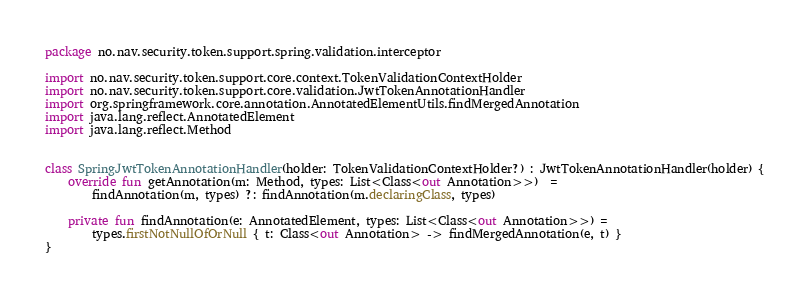Convert code to text. <code><loc_0><loc_0><loc_500><loc_500><_Kotlin_>package no.nav.security.token.support.spring.validation.interceptor

import no.nav.security.token.support.core.context.TokenValidationContextHolder
import no.nav.security.token.support.core.validation.JwtTokenAnnotationHandler
import org.springframework.core.annotation.AnnotatedElementUtils.findMergedAnnotation
import java.lang.reflect.AnnotatedElement
import java.lang.reflect.Method


class SpringJwtTokenAnnotationHandler(holder: TokenValidationContextHolder?) : JwtTokenAnnotationHandler(holder) {
    override fun getAnnotation(m: Method, types: List<Class<out Annotation>>)  =
        findAnnotation(m, types) ?: findAnnotation(m.declaringClass, types)

    private fun findAnnotation(e: AnnotatedElement, types: List<Class<out Annotation>>) =
        types.firstNotNullOfOrNull { t: Class<out Annotation> -> findMergedAnnotation(e, t) }
}</code> 